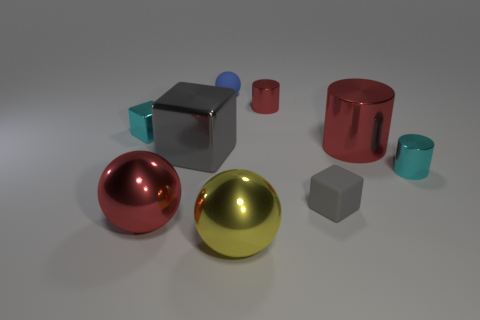Subtract all yellow blocks. How many red cylinders are left? 2 Add 1 blue matte things. How many objects exist? 10 Subtract all cylinders. How many objects are left? 6 Subtract all cyan things. Subtract all cubes. How many objects are left? 4 Add 8 cyan objects. How many cyan objects are left? 10 Add 1 big green cylinders. How many big green cylinders exist? 1 Subtract 0 gray balls. How many objects are left? 9 